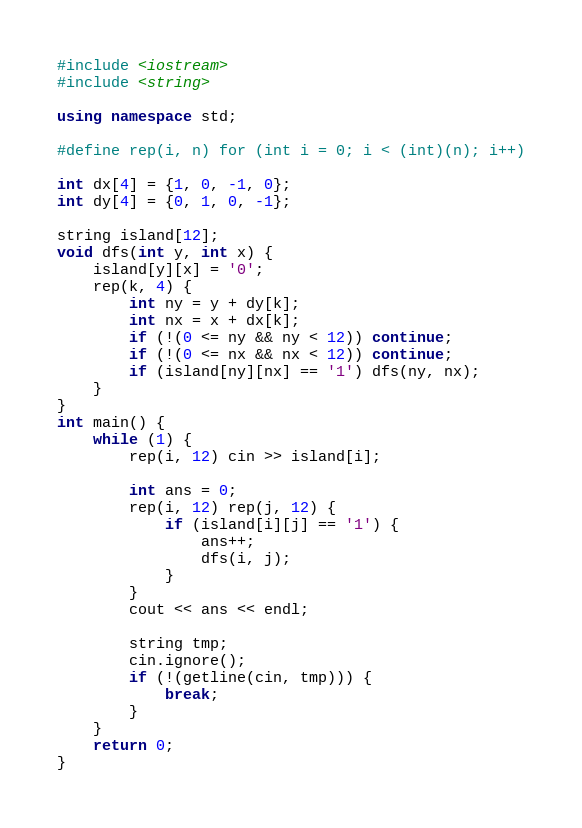Convert code to text. <code><loc_0><loc_0><loc_500><loc_500><_C++_>#include <iostream>
#include <string>

using namespace std;

#define rep(i, n) for (int i = 0; i < (int)(n); i++)

int dx[4] = {1, 0, -1, 0};
int dy[4] = {0, 1, 0, -1};

string island[12];
void dfs(int y, int x) {
    island[y][x] = '0';
    rep(k, 4) {
        int ny = y + dy[k];
        int nx = x + dx[k];
        if (!(0 <= ny && ny < 12)) continue;
        if (!(0 <= nx && nx < 12)) continue;
        if (island[ny][nx] == '1') dfs(ny, nx);
    }
}
int main() {
    while (1) {
        rep(i, 12) cin >> island[i];

        int ans = 0;
        rep(i, 12) rep(j, 12) {
            if (island[i][j] == '1') {
                ans++;
                dfs(i, j);
            }
        }
        cout << ans << endl;

        string tmp;
        cin.ignore();
        if (!(getline(cin, tmp))) {
            break;
        }
    }
    return 0;
}</code> 